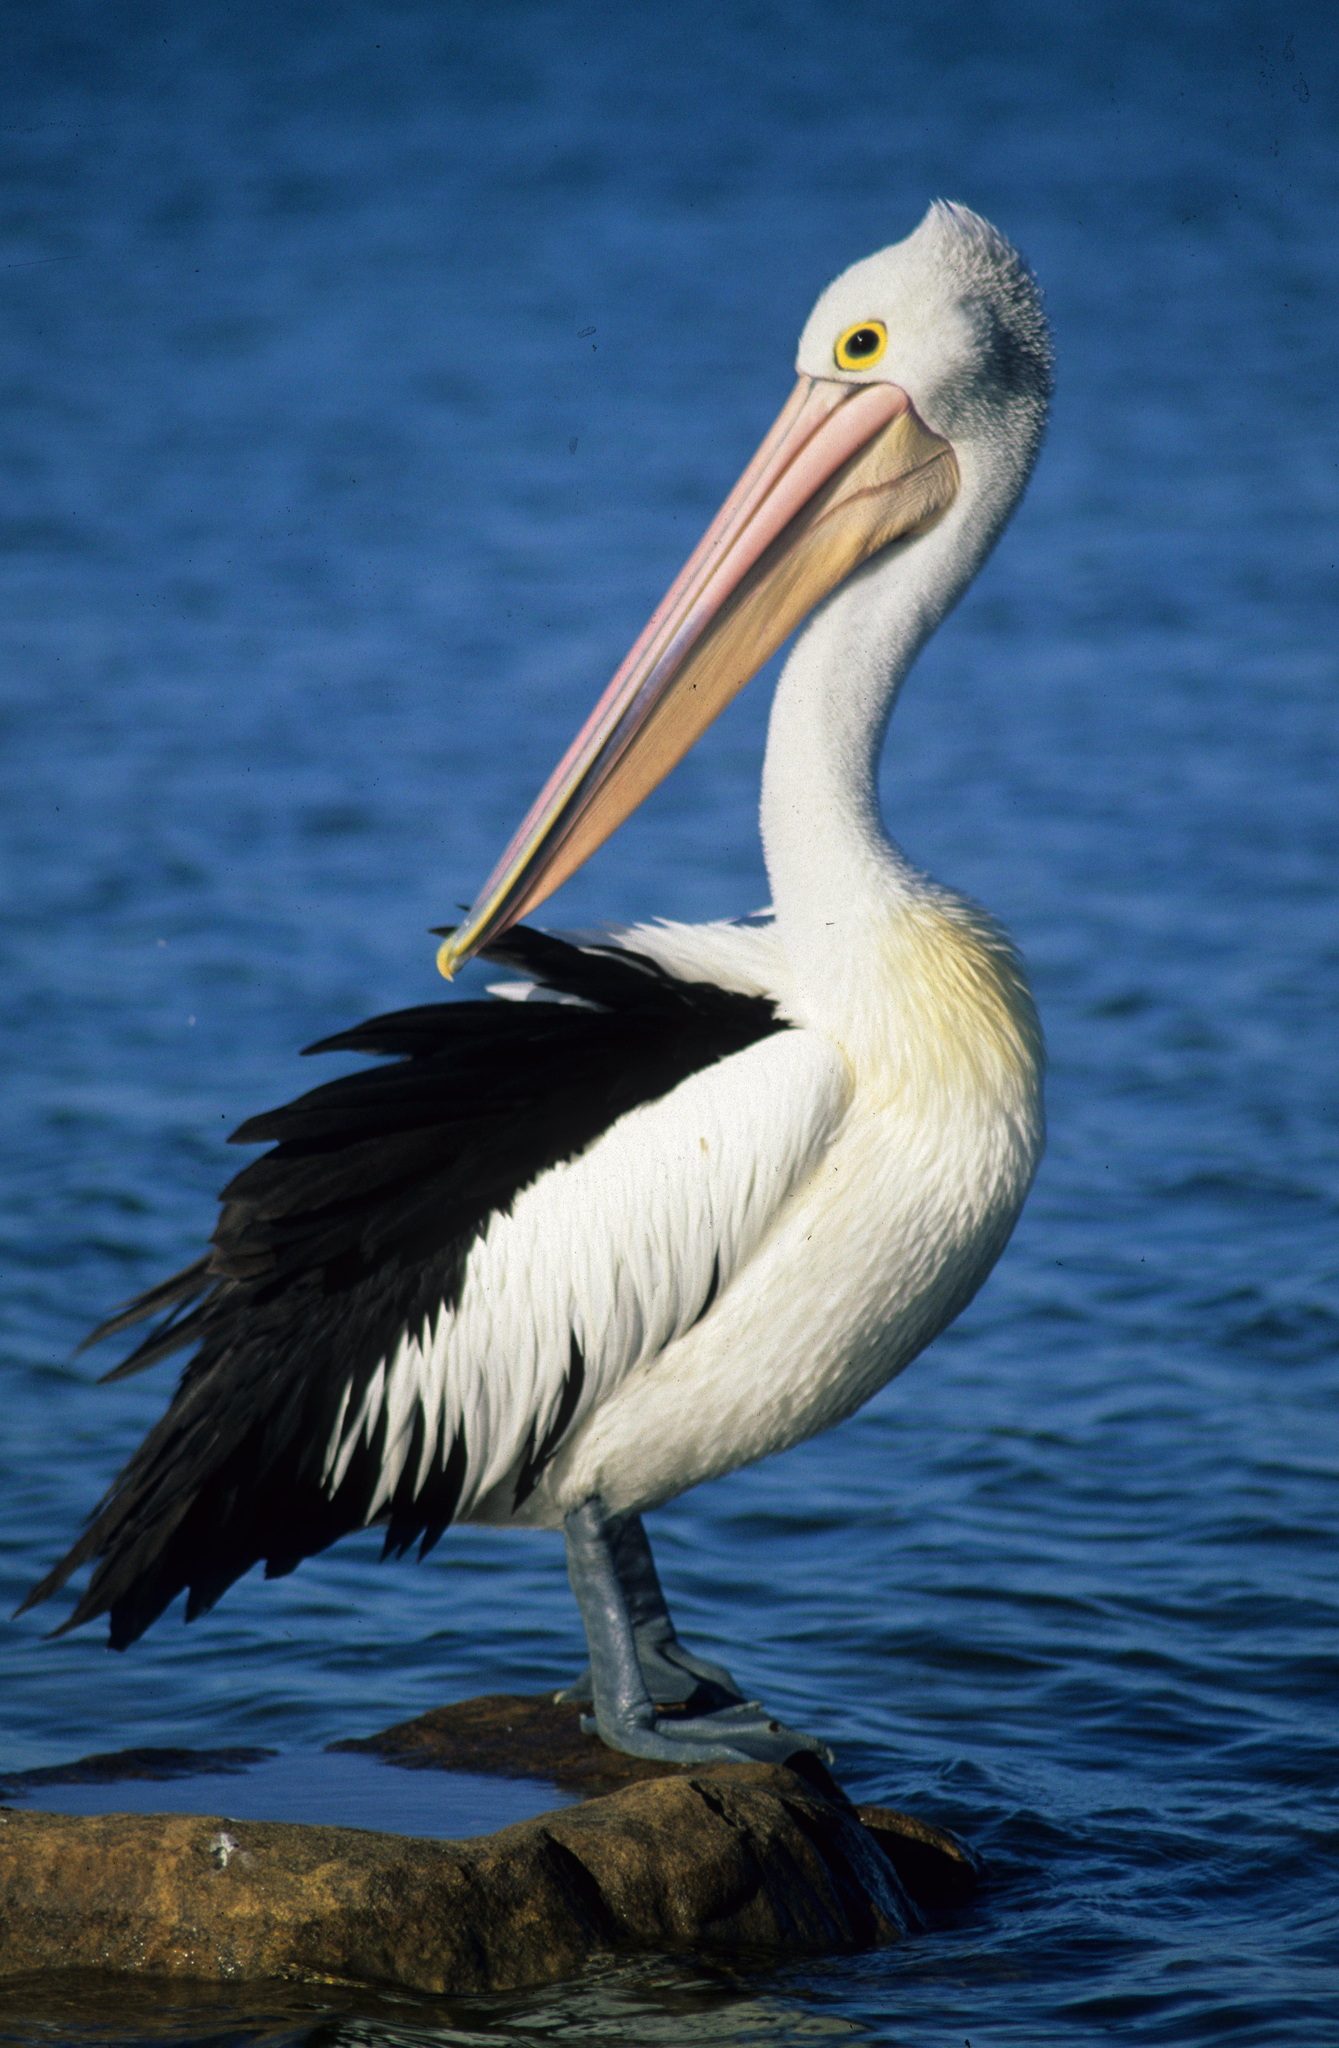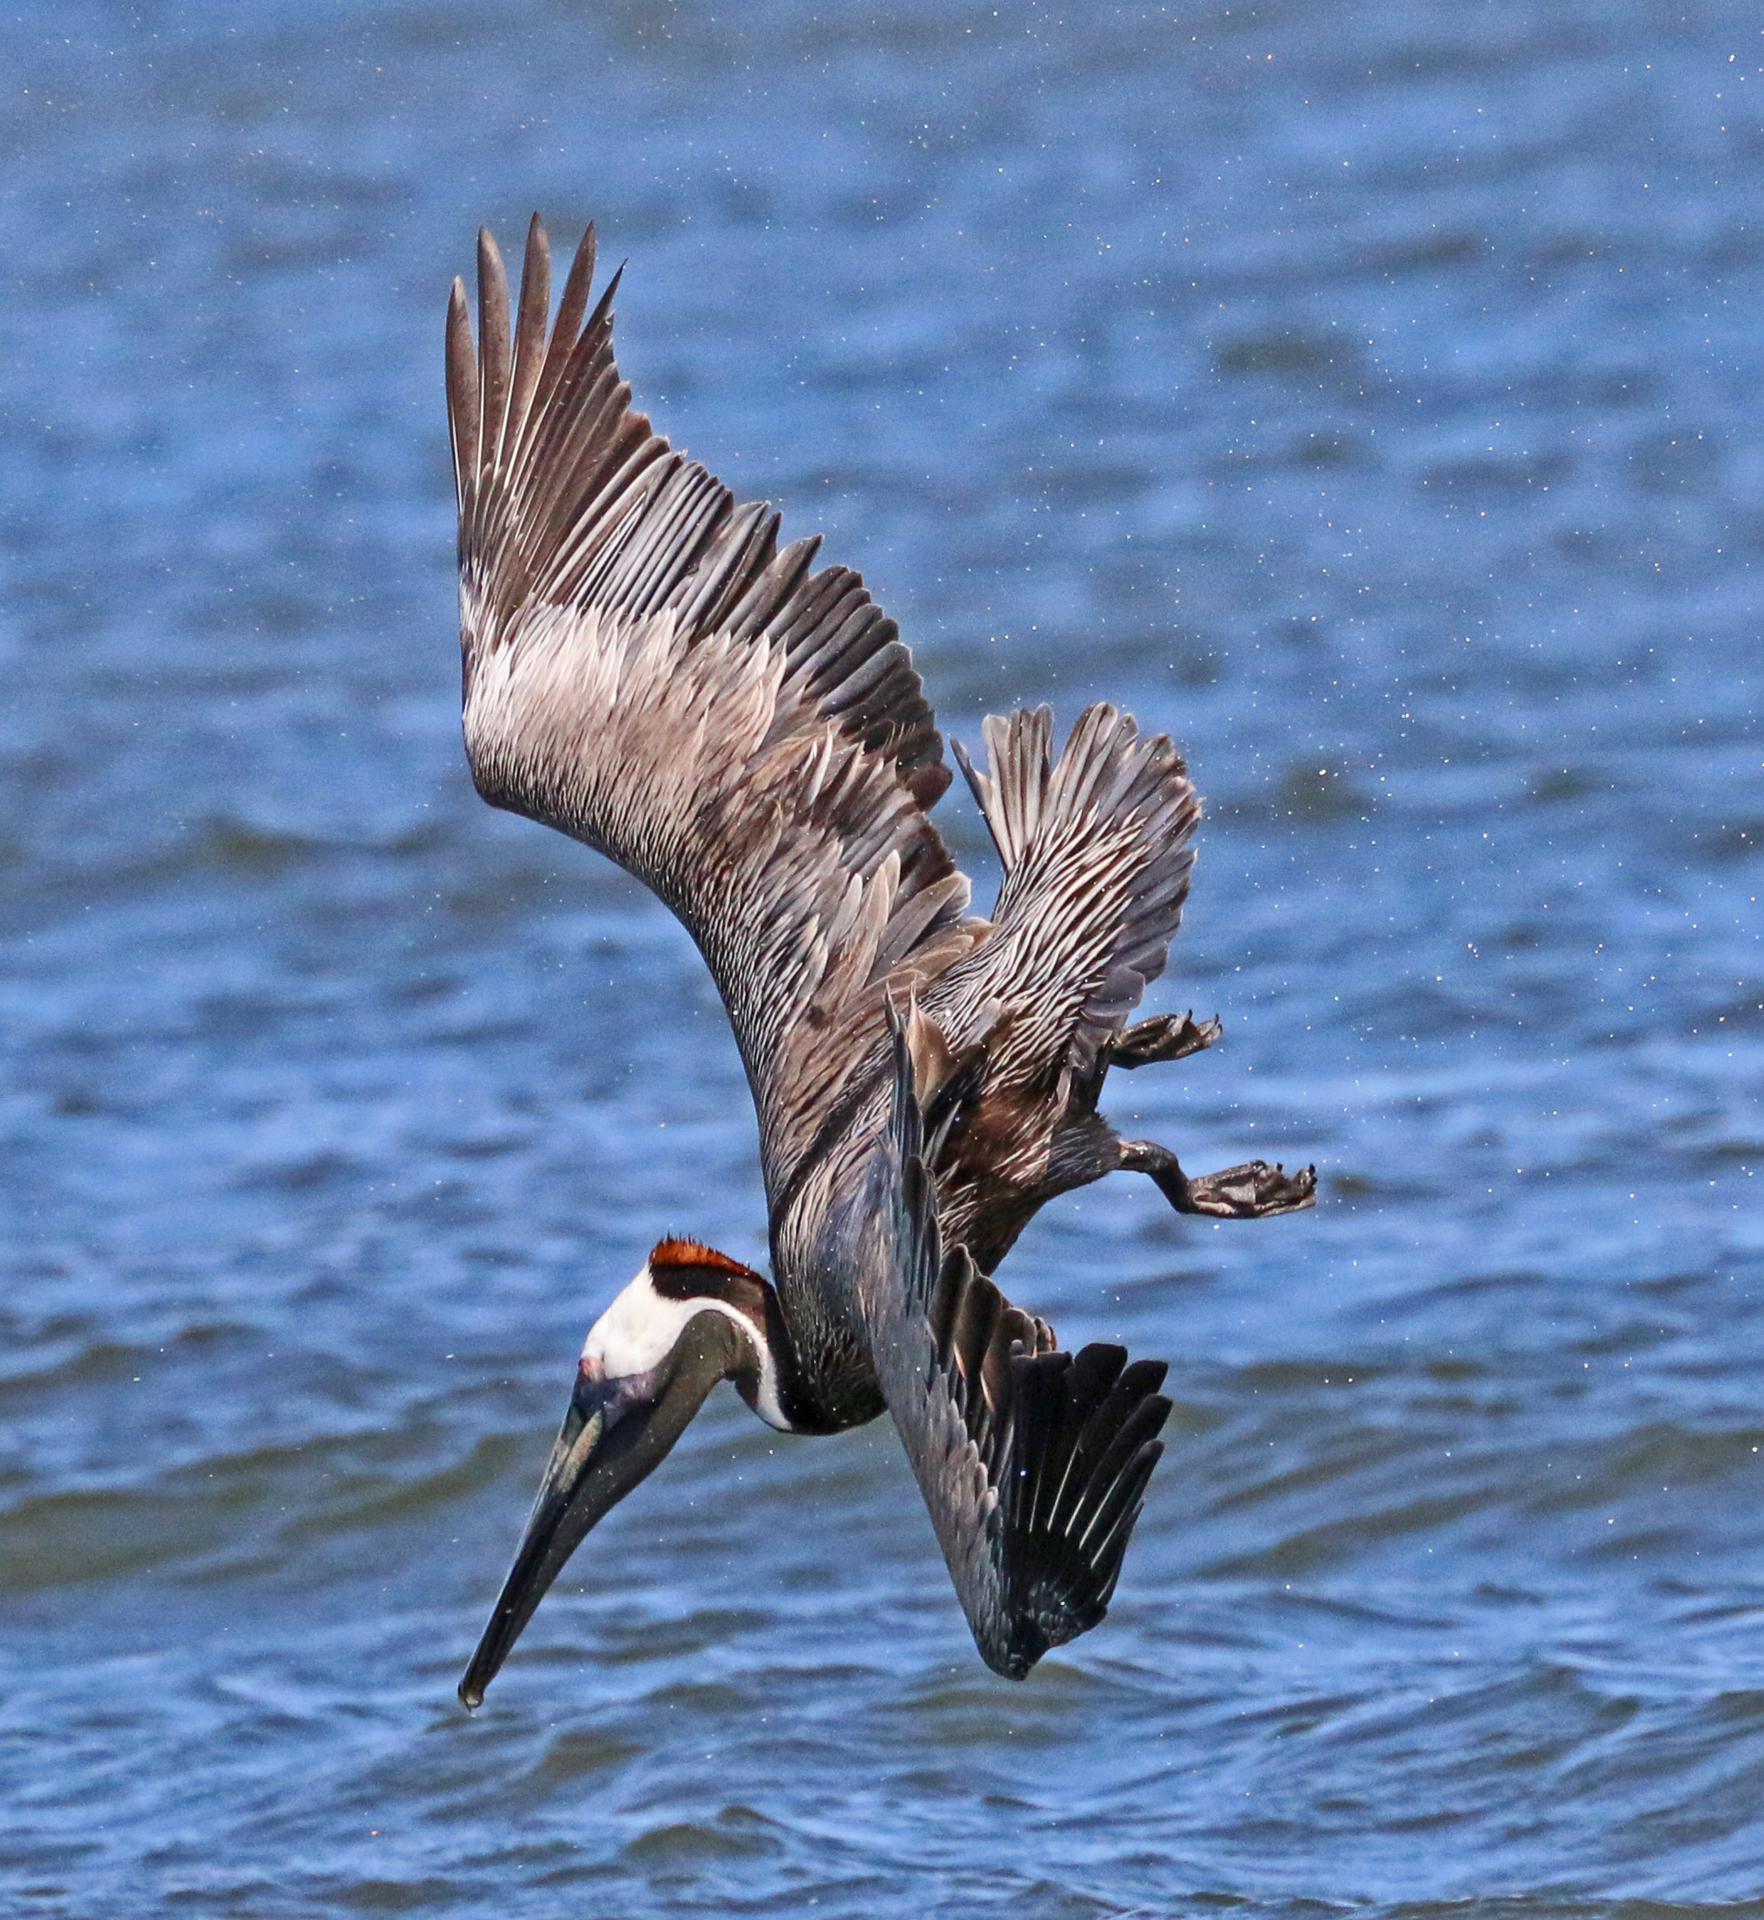The first image is the image on the left, the second image is the image on the right. Considering the images on both sides, is "An image shows one white-bodied pelican above blue water, with outstretched wings." valid? Answer yes or no. No. The first image is the image on the left, the second image is the image on the right. Analyze the images presented: Is the assertion "At least one bird is sitting in water." valid? Answer yes or no. No. 